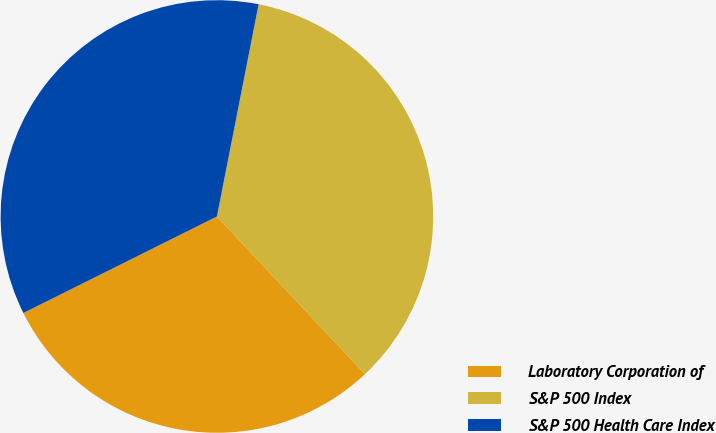Convert chart. <chart><loc_0><loc_0><loc_500><loc_500><pie_chart><fcel>Laboratory Corporation of<fcel>S&P 500 Index<fcel>S&P 500 Health Care Index<nl><fcel>29.64%<fcel>34.91%<fcel>35.45%<nl></chart> 